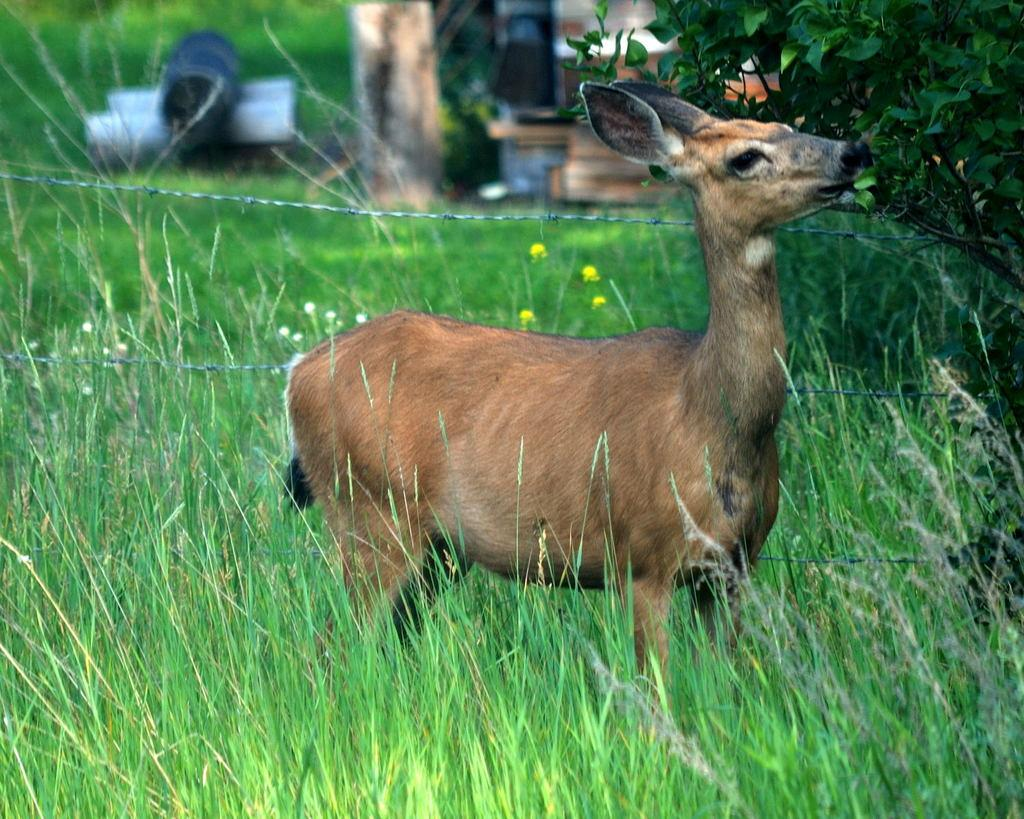What type of animal is in the image? There is an animal in the image, but its specific type cannot be determined from the provided facts. Can you describe the coloring of the animal? The animal has brown, black, and cream coloring. What type of vegetation is visible in the image? There is green grass in the image. What other objects can be seen in the image? There is a tree and fencing in the image. How would you describe the background of the image? The background of the image is blurry. How does the animal express its hatred for water in the image? There is no indication in the image that the animal has any feelings towards water, and therefore no such expression can be observed. 